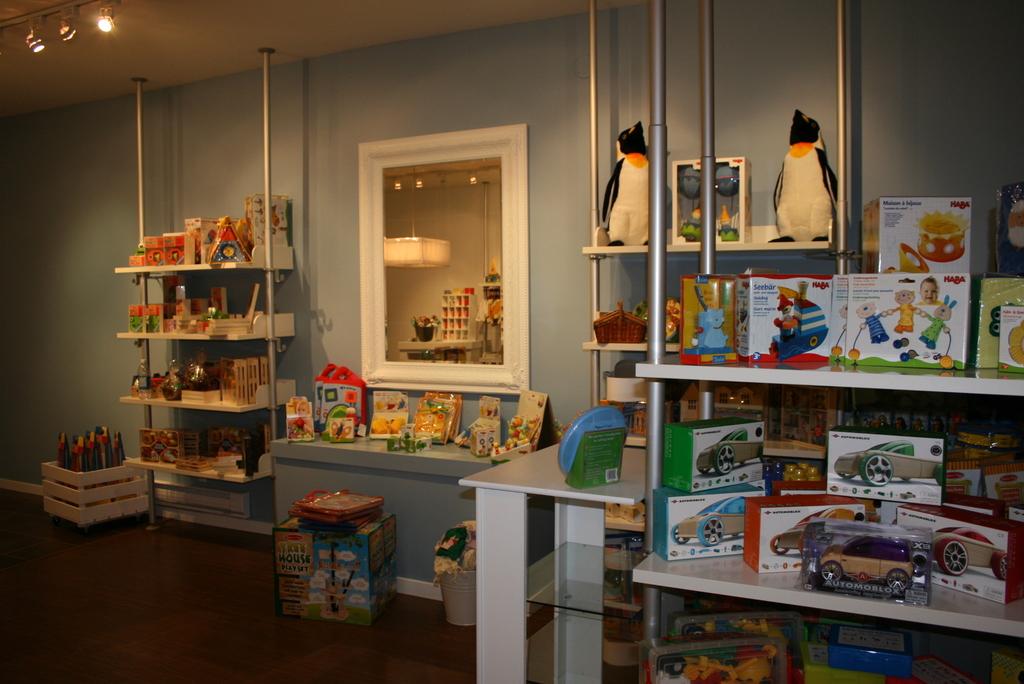What is the name of the toy in the clear box on the shelf on the right?
Provide a succinct answer. Unanswerable. 